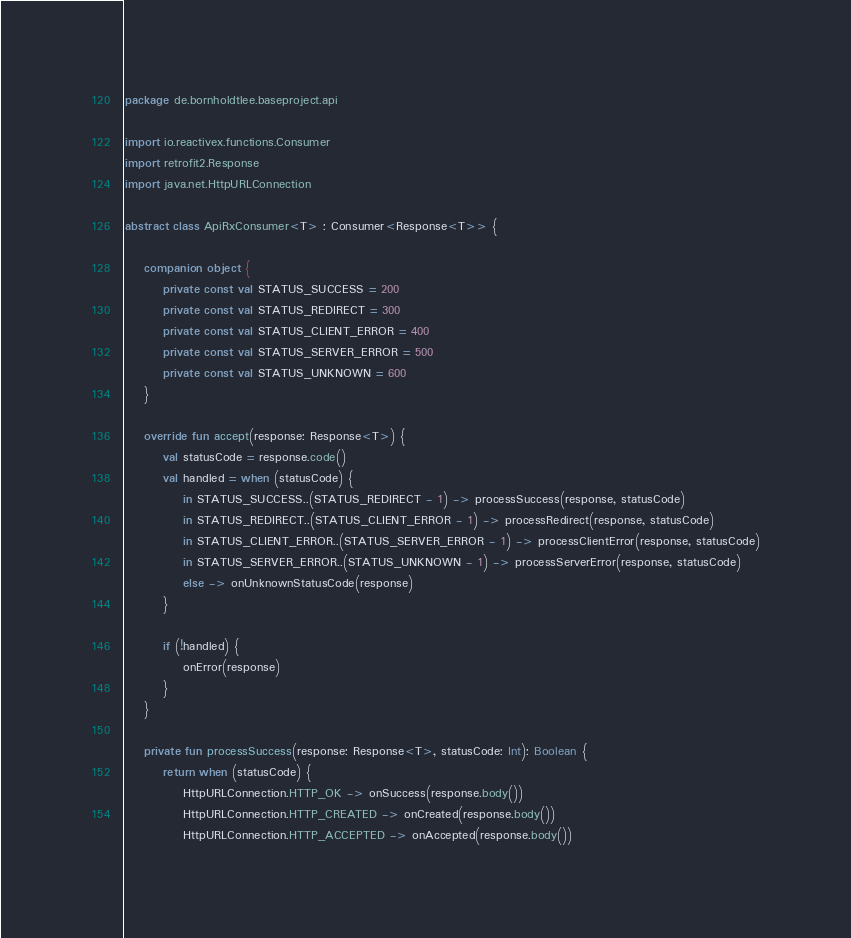Convert code to text. <code><loc_0><loc_0><loc_500><loc_500><_Kotlin_>package de.bornholdtlee.baseproject.api

import io.reactivex.functions.Consumer
import retrofit2.Response
import java.net.HttpURLConnection

abstract class ApiRxConsumer<T> : Consumer<Response<T>> {

    companion object {
        private const val STATUS_SUCCESS = 200
        private const val STATUS_REDIRECT = 300
        private const val STATUS_CLIENT_ERROR = 400
        private const val STATUS_SERVER_ERROR = 500
        private const val STATUS_UNKNOWN = 600
    }

    override fun accept(response: Response<T>) {
        val statusCode = response.code()
        val handled = when (statusCode) {
            in STATUS_SUCCESS..(STATUS_REDIRECT - 1) -> processSuccess(response, statusCode)
            in STATUS_REDIRECT..(STATUS_CLIENT_ERROR - 1) -> processRedirect(response, statusCode)
            in STATUS_CLIENT_ERROR..(STATUS_SERVER_ERROR - 1) -> processClientError(response, statusCode)
            in STATUS_SERVER_ERROR..(STATUS_UNKNOWN - 1) -> processServerError(response, statusCode)
            else -> onUnknownStatusCode(response)
        }

        if (!handled) {
            onError(response)
        }
    }

    private fun processSuccess(response: Response<T>, statusCode: Int): Boolean {
        return when (statusCode) {
            HttpURLConnection.HTTP_OK -> onSuccess(response.body())
            HttpURLConnection.HTTP_CREATED -> onCreated(response.body())
            HttpURLConnection.HTTP_ACCEPTED -> onAccepted(response.body())</code> 